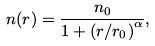<formula> <loc_0><loc_0><loc_500><loc_500>n ( r ) = \frac { n _ { 0 } } { 1 + \left ( r / r _ { 0 } \right ) ^ { \alpha } } ,</formula> 